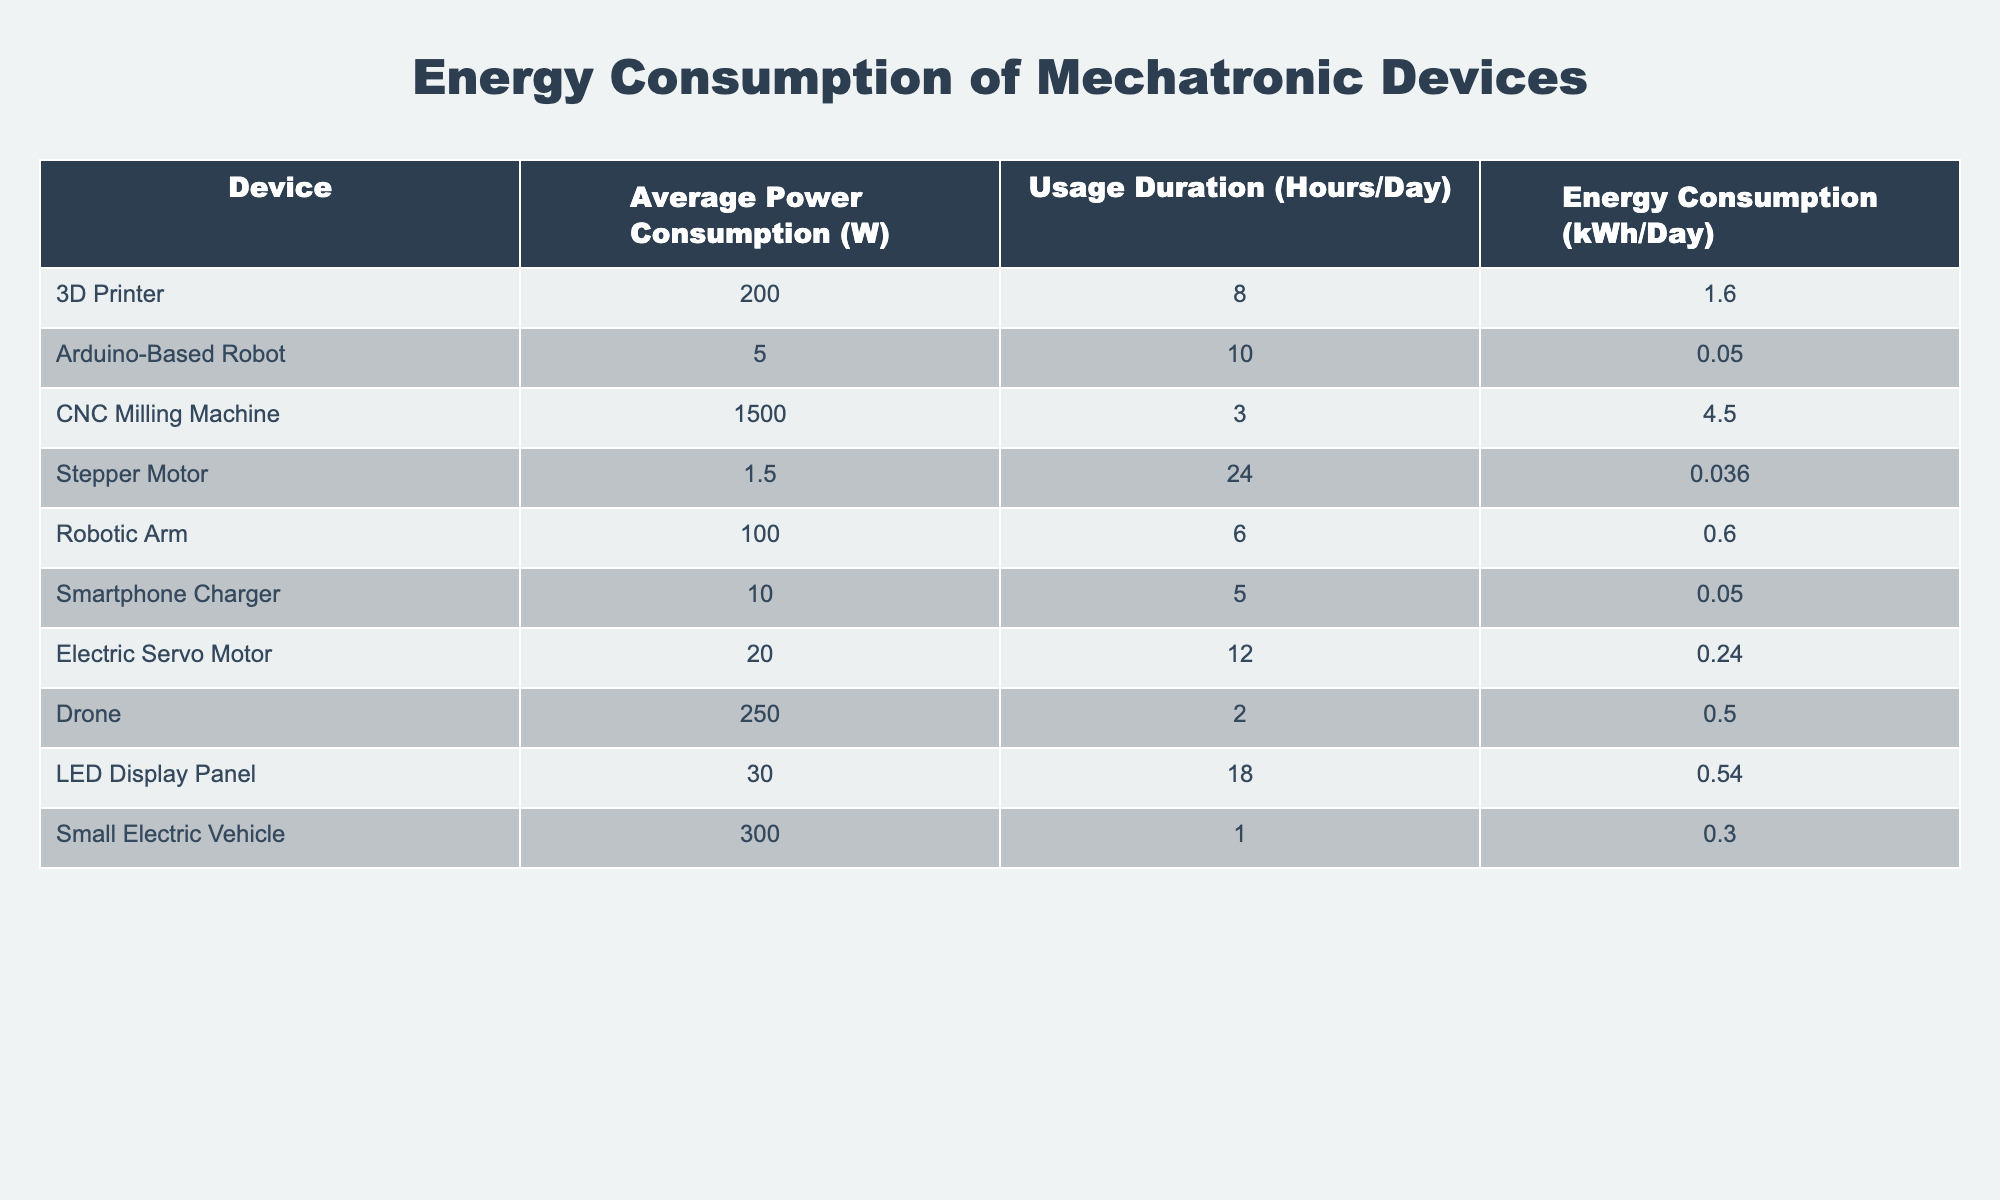What is the average power consumption of a 3D Printer? The table shows that the Average Power Consumption for a 3D Printer is listed under the corresponding column. Therefore, the value is 200 W.
Answer: 200 W Which device has the lowest energy consumption per day? By comparing the Energy Consumption values of all devices in the table, the Arduino-Based Robot has the lowest energy consumption at 0.05 kWh/Day.
Answer: Arduino-Based Robot What is the total energy consumption of all devices combined? Summing the Energy Consumption of each device: 1.6 + 0.05 + 4.5 + 0.036 + 0.6 + 0.05 + 0.24 + 0.5 + 0.54 + 0.3 = 8.53 kWh/Day total.
Answer: 8.53 kWh/Day Does a CNC Milling Machine consume more energy than a Small Electric Vehicle? The CNC Milling Machine consumes 4.5 kWh/Day while the Small Electric Vehicle consumes 0.3 kWh/Day, meaning it does consume more energy.
Answer: Yes What is the percentage contribution of the Drone's energy consumption to the total energy consumption? First, we know the total energy consumption is 8.53 kWh/Day. The Drone consumes 0.5 kWh/Day. To find the percentage: (0.5 / 8.53) * 100 = 5.86%. Thus, the Drone contributes approximately 5.86% to the total.
Answer: 5.86% 